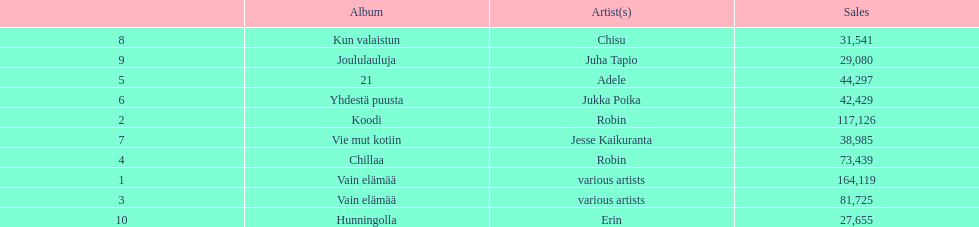How many albums sold for than 50,000 copies this year? 4. 